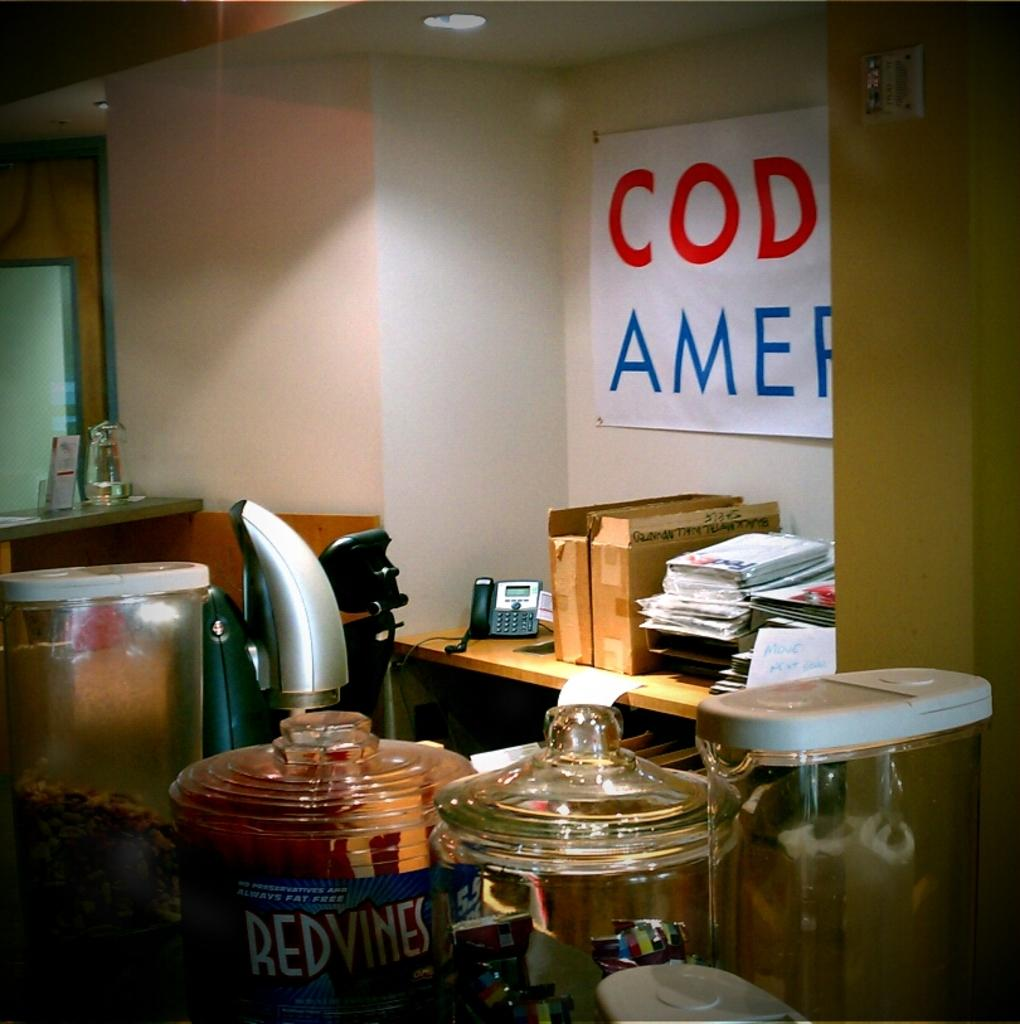<image>
Summarize the visual content of the image. A jar of Red Vines is on a counter amongst other containers. 